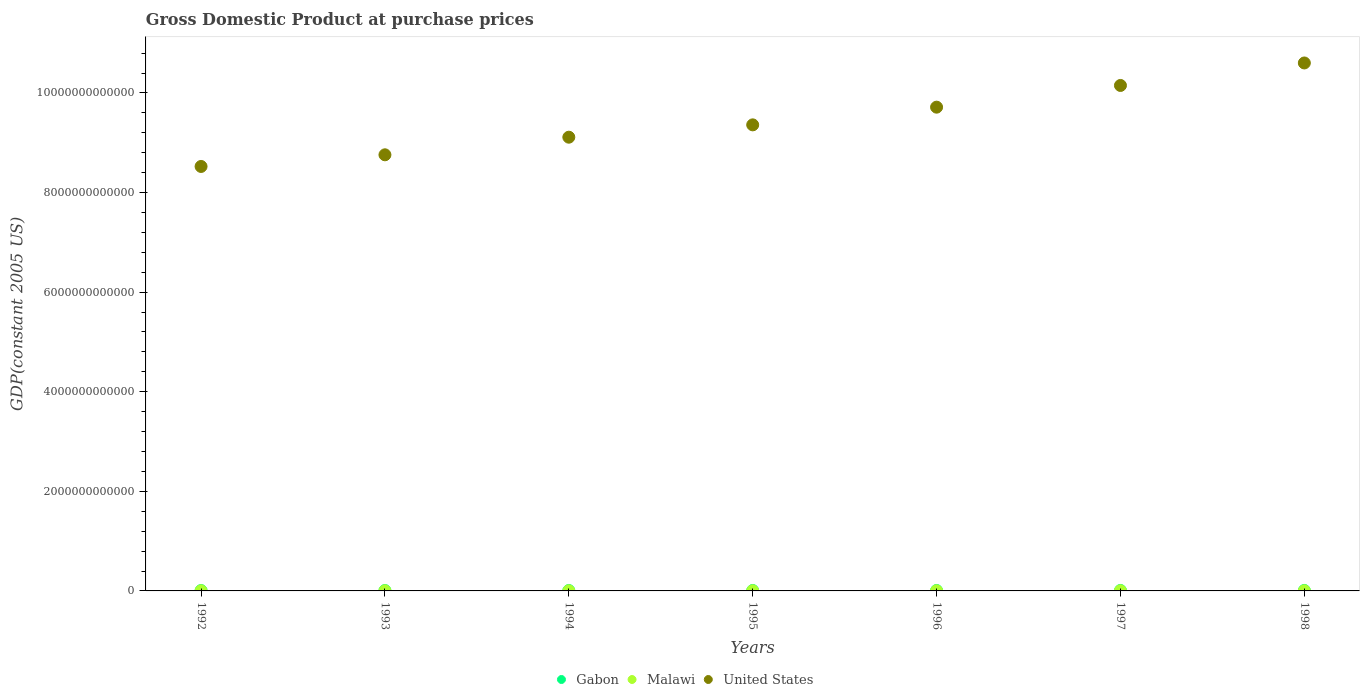Is the number of dotlines equal to the number of legend labels?
Your answer should be compact. Yes. What is the GDP at purchase prices in United States in 1994?
Offer a terse response. 9.11e+12. Across all years, what is the maximum GDP at purchase prices in Gabon?
Your response must be concise. 9.71e+09. Across all years, what is the minimum GDP at purchase prices in United States?
Keep it short and to the point. 8.52e+12. What is the total GDP at purchase prices in Gabon in the graph?
Make the answer very short. 6.01e+1. What is the difference between the GDP at purchase prices in Malawi in 1993 and that in 1994?
Provide a short and direct response. 2.02e+08. What is the difference between the GDP at purchase prices in Malawi in 1992 and the GDP at purchase prices in United States in 1997?
Provide a short and direct response. -1.01e+13. What is the average GDP at purchase prices in Gabon per year?
Provide a succinct answer. 8.59e+09. In the year 1996, what is the difference between the GDP at purchase prices in Malawi and GDP at purchase prices in Gabon?
Ensure brevity in your answer.  -6.66e+09. In how many years, is the GDP at purchase prices in United States greater than 2000000000000 US$?
Your answer should be very brief. 7. What is the ratio of the GDP at purchase prices in United States in 1994 to that in 1996?
Your answer should be compact. 0.94. Is the GDP at purchase prices in Gabon in 1993 less than that in 1998?
Ensure brevity in your answer.  Yes. Is the difference between the GDP at purchase prices in Malawi in 1995 and 1998 greater than the difference between the GDP at purchase prices in Gabon in 1995 and 1998?
Make the answer very short. Yes. What is the difference between the highest and the second highest GDP at purchase prices in Gabon?
Offer a very short reply. 3.26e+08. What is the difference between the highest and the lowest GDP at purchase prices in Malawi?
Ensure brevity in your answer.  6.22e+08. Is it the case that in every year, the sum of the GDP at purchase prices in Malawi and GDP at purchase prices in United States  is greater than the GDP at purchase prices in Gabon?
Make the answer very short. Yes. Is the GDP at purchase prices in United States strictly greater than the GDP at purchase prices in Gabon over the years?
Offer a terse response. Yes. What is the difference between two consecutive major ticks on the Y-axis?
Your answer should be very brief. 2.00e+12. Are the values on the major ticks of Y-axis written in scientific E-notation?
Your answer should be very brief. No. Does the graph contain grids?
Your answer should be very brief. No. What is the title of the graph?
Provide a succinct answer. Gross Domestic Product at purchase prices. Does "Pacific island small states" appear as one of the legend labels in the graph?
Give a very brief answer. No. What is the label or title of the Y-axis?
Provide a short and direct response. GDP(constant 2005 US). What is the GDP(constant 2005 US) of Gabon in 1992?
Offer a very short reply. 7.57e+09. What is the GDP(constant 2005 US) in Malawi in 1992?
Ensure brevity in your answer.  1.80e+09. What is the GDP(constant 2005 US) of United States in 1992?
Provide a succinct answer. 8.52e+12. What is the GDP(constant 2005 US) in Gabon in 1993?
Keep it short and to the point. 7.87e+09. What is the GDP(constant 2005 US) in Malawi in 1993?
Make the answer very short. 1.97e+09. What is the GDP(constant 2005 US) in United States in 1993?
Keep it short and to the point. 8.76e+12. What is the GDP(constant 2005 US) in Gabon in 1994?
Offer a very short reply. 8.16e+09. What is the GDP(constant 2005 US) of Malawi in 1994?
Provide a succinct answer. 1.77e+09. What is the GDP(constant 2005 US) in United States in 1994?
Give a very brief answer. 9.11e+12. What is the GDP(constant 2005 US) in Gabon in 1995?
Provide a succinct answer. 8.57e+09. What is the GDP(constant 2005 US) in Malawi in 1995?
Keep it short and to the point. 2.07e+09. What is the GDP(constant 2005 US) in United States in 1995?
Give a very brief answer. 9.36e+12. What is the GDP(constant 2005 US) in Gabon in 1996?
Your response must be concise. 8.88e+09. What is the GDP(constant 2005 US) in Malawi in 1996?
Ensure brevity in your answer.  2.22e+09. What is the GDP(constant 2005 US) in United States in 1996?
Make the answer very short. 9.71e+12. What is the GDP(constant 2005 US) in Gabon in 1997?
Provide a succinct answer. 9.39e+09. What is the GDP(constant 2005 US) in Malawi in 1997?
Offer a terse response. 2.30e+09. What is the GDP(constant 2005 US) in United States in 1997?
Provide a short and direct response. 1.02e+13. What is the GDP(constant 2005 US) of Gabon in 1998?
Your answer should be compact. 9.71e+09. What is the GDP(constant 2005 US) in Malawi in 1998?
Offer a terse response. 2.39e+09. What is the GDP(constant 2005 US) in United States in 1998?
Provide a succinct answer. 1.06e+13. Across all years, what is the maximum GDP(constant 2005 US) of Gabon?
Your response must be concise. 9.71e+09. Across all years, what is the maximum GDP(constant 2005 US) of Malawi?
Ensure brevity in your answer.  2.39e+09. Across all years, what is the maximum GDP(constant 2005 US) in United States?
Provide a short and direct response. 1.06e+13. Across all years, what is the minimum GDP(constant 2005 US) of Gabon?
Give a very brief answer. 7.57e+09. Across all years, what is the minimum GDP(constant 2005 US) of Malawi?
Provide a succinct answer. 1.77e+09. Across all years, what is the minimum GDP(constant 2005 US) in United States?
Make the answer very short. 8.52e+12. What is the total GDP(constant 2005 US) of Gabon in the graph?
Keep it short and to the point. 6.01e+1. What is the total GDP(constant 2005 US) of Malawi in the graph?
Keep it short and to the point. 1.45e+1. What is the total GDP(constant 2005 US) in United States in the graph?
Provide a short and direct response. 6.62e+13. What is the difference between the GDP(constant 2005 US) in Gabon in 1992 and that in 1993?
Offer a very short reply. -2.99e+08. What is the difference between the GDP(constant 2005 US) of Malawi in 1992 and that in 1993?
Your response must be concise. -1.74e+08. What is the difference between the GDP(constant 2005 US) of United States in 1992 and that in 1993?
Offer a very short reply. -2.34e+11. What is the difference between the GDP(constant 2005 US) of Gabon in 1992 and that in 1994?
Your answer should be compact. -5.91e+08. What is the difference between the GDP(constant 2005 US) of Malawi in 1992 and that in 1994?
Ensure brevity in your answer.  2.77e+07. What is the difference between the GDP(constant 2005 US) in United States in 1992 and that in 1994?
Make the answer very short. -5.88e+11. What is the difference between the GDP(constant 2005 US) of Gabon in 1992 and that in 1995?
Offer a very short reply. -9.97e+08. What is the difference between the GDP(constant 2005 US) of Malawi in 1992 and that in 1995?
Your answer should be very brief. -2.69e+08. What is the difference between the GDP(constant 2005 US) of United States in 1992 and that in 1995?
Offer a very short reply. -8.35e+11. What is the difference between the GDP(constant 2005 US) of Gabon in 1992 and that in 1996?
Provide a succinct answer. -1.31e+09. What is the difference between the GDP(constant 2005 US) in Malawi in 1992 and that in 1996?
Offer a terse response. -4.20e+08. What is the difference between the GDP(constant 2005 US) in United States in 1992 and that in 1996?
Ensure brevity in your answer.  -1.19e+12. What is the difference between the GDP(constant 2005 US) in Gabon in 1992 and that in 1997?
Your answer should be compact. -1.82e+09. What is the difference between the GDP(constant 2005 US) of Malawi in 1992 and that in 1997?
Provide a short and direct response. -5.04e+08. What is the difference between the GDP(constant 2005 US) of United States in 1992 and that in 1997?
Provide a short and direct response. -1.63e+12. What is the difference between the GDP(constant 2005 US) in Gabon in 1992 and that in 1998?
Your answer should be very brief. -2.14e+09. What is the difference between the GDP(constant 2005 US) of Malawi in 1992 and that in 1998?
Provide a succinct answer. -5.94e+08. What is the difference between the GDP(constant 2005 US) in United States in 1992 and that in 1998?
Ensure brevity in your answer.  -2.08e+12. What is the difference between the GDP(constant 2005 US) in Gabon in 1993 and that in 1994?
Offer a terse response. -2.92e+08. What is the difference between the GDP(constant 2005 US) of Malawi in 1993 and that in 1994?
Give a very brief answer. 2.02e+08. What is the difference between the GDP(constant 2005 US) of United States in 1993 and that in 1994?
Ensure brevity in your answer.  -3.54e+11. What is the difference between the GDP(constant 2005 US) of Gabon in 1993 and that in 1995?
Offer a very short reply. -6.98e+08. What is the difference between the GDP(constant 2005 US) in Malawi in 1993 and that in 1995?
Your answer should be compact. -9.43e+07. What is the difference between the GDP(constant 2005 US) of United States in 1993 and that in 1995?
Offer a very short reply. -6.01e+11. What is the difference between the GDP(constant 2005 US) of Gabon in 1993 and that in 1996?
Provide a succinct answer. -1.01e+09. What is the difference between the GDP(constant 2005 US) of Malawi in 1993 and that in 1996?
Provide a succinct answer. -2.46e+08. What is the difference between the GDP(constant 2005 US) in United States in 1993 and that in 1996?
Offer a terse response. -9.57e+11. What is the difference between the GDP(constant 2005 US) of Gabon in 1993 and that in 1997?
Offer a very short reply. -1.52e+09. What is the difference between the GDP(constant 2005 US) in Malawi in 1993 and that in 1997?
Provide a short and direct response. -3.30e+08. What is the difference between the GDP(constant 2005 US) of United States in 1993 and that in 1997?
Offer a terse response. -1.39e+12. What is the difference between the GDP(constant 2005 US) in Gabon in 1993 and that in 1998?
Provide a succinct answer. -1.84e+09. What is the difference between the GDP(constant 2005 US) of Malawi in 1993 and that in 1998?
Provide a succinct answer. -4.20e+08. What is the difference between the GDP(constant 2005 US) of United States in 1993 and that in 1998?
Offer a terse response. -1.84e+12. What is the difference between the GDP(constant 2005 US) in Gabon in 1994 and that in 1995?
Your response must be concise. -4.06e+08. What is the difference between the GDP(constant 2005 US) in Malawi in 1994 and that in 1995?
Your answer should be compact. -2.97e+08. What is the difference between the GDP(constant 2005 US) of United States in 1994 and that in 1995?
Keep it short and to the point. -2.48e+11. What is the difference between the GDP(constant 2005 US) of Gabon in 1994 and that in 1996?
Offer a terse response. -7.16e+08. What is the difference between the GDP(constant 2005 US) in Malawi in 1994 and that in 1996?
Provide a short and direct response. -4.48e+08. What is the difference between the GDP(constant 2005 US) of United States in 1994 and that in 1996?
Offer a very short reply. -6.03e+11. What is the difference between the GDP(constant 2005 US) of Gabon in 1994 and that in 1997?
Keep it short and to the point. -1.23e+09. What is the difference between the GDP(constant 2005 US) of Malawi in 1994 and that in 1997?
Provide a short and direct response. -5.32e+08. What is the difference between the GDP(constant 2005 US) in United States in 1994 and that in 1997?
Your answer should be very brief. -1.04e+12. What is the difference between the GDP(constant 2005 US) in Gabon in 1994 and that in 1998?
Provide a short and direct response. -1.55e+09. What is the difference between the GDP(constant 2005 US) of Malawi in 1994 and that in 1998?
Offer a terse response. -6.22e+08. What is the difference between the GDP(constant 2005 US) of United States in 1994 and that in 1998?
Make the answer very short. -1.49e+12. What is the difference between the GDP(constant 2005 US) of Gabon in 1995 and that in 1996?
Keep it short and to the point. -3.11e+08. What is the difference between the GDP(constant 2005 US) in Malawi in 1995 and that in 1996?
Make the answer very short. -1.51e+08. What is the difference between the GDP(constant 2005 US) in United States in 1995 and that in 1996?
Keep it short and to the point. -3.55e+11. What is the difference between the GDP(constant 2005 US) of Gabon in 1995 and that in 1997?
Provide a succinct answer. -8.20e+08. What is the difference between the GDP(constant 2005 US) in Malawi in 1995 and that in 1997?
Your answer should be very brief. -2.36e+08. What is the difference between the GDP(constant 2005 US) of United States in 1995 and that in 1997?
Keep it short and to the point. -7.91e+11. What is the difference between the GDP(constant 2005 US) of Gabon in 1995 and that in 1998?
Your answer should be compact. -1.15e+09. What is the difference between the GDP(constant 2005 US) of Malawi in 1995 and that in 1998?
Give a very brief answer. -3.25e+08. What is the difference between the GDP(constant 2005 US) in United States in 1995 and that in 1998?
Provide a short and direct response. -1.24e+12. What is the difference between the GDP(constant 2005 US) of Gabon in 1996 and that in 1997?
Your answer should be very brief. -5.09e+08. What is the difference between the GDP(constant 2005 US) in Malawi in 1996 and that in 1997?
Keep it short and to the point. -8.42e+07. What is the difference between the GDP(constant 2005 US) of United States in 1996 and that in 1997?
Your answer should be compact. -4.36e+11. What is the difference between the GDP(constant 2005 US) of Gabon in 1996 and that in 1998?
Offer a terse response. -8.36e+08. What is the difference between the GDP(constant 2005 US) in Malawi in 1996 and that in 1998?
Your response must be concise. -1.74e+08. What is the difference between the GDP(constant 2005 US) in United States in 1996 and that in 1998?
Ensure brevity in your answer.  -8.88e+11. What is the difference between the GDP(constant 2005 US) of Gabon in 1997 and that in 1998?
Provide a succinct answer. -3.26e+08. What is the difference between the GDP(constant 2005 US) in Malawi in 1997 and that in 1998?
Your answer should be very brief. -8.98e+07. What is the difference between the GDP(constant 2005 US) in United States in 1997 and that in 1998?
Provide a succinct answer. -4.52e+11. What is the difference between the GDP(constant 2005 US) of Gabon in 1992 and the GDP(constant 2005 US) of Malawi in 1993?
Provide a short and direct response. 5.60e+09. What is the difference between the GDP(constant 2005 US) in Gabon in 1992 and the GDP(constant 2005 US) in United States in 1993?
Offer a terse response. -8.75e+12. What is the difference between the GDP(constant 2005 US) in Malawi in 1992 and the GDP(constant 2005 US) in United States in 1993?
Offer a terse response. -8.76e+12. What is the difference between the GDP(constant 2005 US) of Gabon in 1992 and the GDP(constant 2005 US) of Malawi in 1994?
Provide a succinct answer. 5.80e+09. What is the difference between the GDP(constant 2005 US) in Gabon in 1992 and the GDP(constant 2005 US) in United States in 1994?
Your response must be concise. -9.10e+12. What is the difference between the GDP(constant 2005 US) in Malawi in 1992 and the GDP(constant 2005 US) in United States in 1994?
Provide a short and direct response. -9.11e+12. What is the difference between the GDP(constant 2005 US) in Gabon in 1992 and the GDP(constant 2005 US) in Malawi in 1995?
Your response must be concise. 5.50e+09. What is the difference between the GDP(constant 2005 US) of Gabon in 1992 and the GDP(constant 2005 US) of United States in 1995?
Your response must be concise. -9.35e+12. What is the difference between the GDP(constant 2005 US) of Malawi in 1992 and the GDP(constant 2005 US) of United States in 1995?
Provide a short and direct response. -9.36e+12. What is the difference between the GDP(constant 2005 US) of Gabon in 1992 and the GDP(constant 2005 US) of Malawi in 1996?
Your answer should be compact. 5.35e+09. What is the difference between the GDP(constant 2005 US) in Gabon in 1992 and the GDP(constant 2005 US) in United States in 1996?
Provide a short and direct response. -9.71e+12. What is the difference between the GDP(constant 2005 US) of Malawi in 1992 and the GDP(constant 2005 US) of United States in 1996?
Make the answer very short. -9.71e+12. What is the difference between the GDP(constant 2005 US) of Gabon in 1992 and the GDP(constant 2005 US) of Malawi in 1997?
Give a very brief answer. 5.27e+09. What is the difference between the GDP(constant 2005 US) of Gabon in 1992 and the GDP(constant 2005 US) of United States in 1997?
Ensure brevity in your answer.  -1.01e+13. What is the difference between the GDP(constant 2005 US) in Malawi in 1992 and the GDP(constant 2005 US) in United States in 1997?
Give a very brief answer. -1.01e+13. What is the difference between the GDP(constant 2005 US) of Gabon in 1992 and the GDP(constant 2005 US) of Malawi in 1998?
Your response must be concise. 5.18e+09. What is the difference between the GDP(constant 2005 US) in Gabon in 1992 and the GDP(constant 2005 US) in United States in 1998?
Ensure brevity in your answer.  -1.06e+13. What is the difference between the GDP(constant 2005 US) in Malawi in 1992 and the GDP(constant 2005 US) in United States in 1998?
Provide a succinct answer. -1.06e+13. What is the difference between the GDP(constant 2005 US) of Gabon in 1993 and the GDP(constant 2005 US) of Malawi in 1994?
Ensure brevity in your answer.  6.10e+09. What is the difference between the GDP(constant 2005 US) in Gabon in 1993 and the GDP(constant 2005 US) in United States in 1994?
Offer a very short reply. -9.10e+12. What is the difference between the GDP(constant 2005 US) in Malawi in 1993 and the GDP(constant 2005 US) in United States in 1994?
Provide a succinct answer. -9.11e+12. What is the difference between the GDP(constant 2005 US) of Gabon in 1993 and the GDP(constant 2005 US) of Malawi in 1995?
Your answer should be very brief. 5.80e+09. What is the difference between the GDP(constant 2005 US) in Gabon in 1993 and the GDP(constant 2005 US) in United States in 1995?
Give a very brief answer. -9.35e+12. What is the difference between the GDP(constant 2005 US) in Malawi in 1993 and the GDP(constant 2005 US) in United States in 1995?
Your answer should be very brief. -9.36e+12. What is the difference between the GDP(constant 2005 US) in Gabon in 1993 and the GDP(constant 2005 US) in Malawi in 1996?
Provide a short and direct response. 5.65e+09. What is the difference between the GDP(constant 2005 US) in Gabon in 1993 and the GDP(constant 2005 US) in United States in 1996?
Your answer should be compact. -9.71e+12. What is the difference between the GDP(constant 2005 US) of Malawi in 1993 and the GDP(constant 2005 US) of United States in 1996?
Ensure brevity in your answer.  -9.71e+12. What is the difference between the GDP(constant 2005 US) in Gabon in 1993 and the GDP(constant 2005 US) in Malawi in 1997?
Your response must be concise. 5.56e+09. What is the difference between the GDP(constant 2005 US) of Gabon in 1993 and the GDP(constant 2005 US) of United States in 1997?
Make the answer very short. -1.01e+13. What is the difference between the GDP(constant 2005 US) of Malawi in 1993 and the GDP(constant 2005 US) of United States in 1997?
Offer a terse response. -1.01e+13. What is the difference between the GDP(constant 2005 US) of Gabon in 1993 and the GDP(constant 2005 US) of Malawi in 1998?
Ensure brevity in your answer.  5.47e+09. What is the difference between the GDP(constant 2005 US) in Gabon in 1993 and the GDP(constant 2005 US) in United States in 1998?
Provide a short and direct response. -1.06e+13. What is the difference between the GDP(constant 2005 US) in Malawi in 1993 and the GDP(constant 2005 US) in United States in 1998?
Ensure brevity in your answer.  -1.06e+13. What is the difference between the GDP(constant 2005 US) of Gabon in 1994 and the GDP(constant 2005 US) of Malawi in 1995?
Your answer should be very brief. 6.09e+09. What is the difference between the GDP(constant 2005 US) of Gabon in 1994 and the GDP(constant 2005 US) of United States in 1995?
Give a very brief answer. -9.35e+12. What is the difference between the GDP(constant 2005 US) in Malawi in 1994 and the GDP(constant 2005 US) in United States in 1995?
Keep it short and to the point. -9.36e+12. What is the difference between the GDP(constant 2005 US) in Gabon in 1994 and the GDP(constant 2005 US) in Malawi in 1996?
Your response must be concise. 5.94e+09. What is the difference between the GDP(constant 2005 US) of Gabon in 1994 and the GDP(constant 2005 US) of United States in 1996?
Keep it short and to the point. -9.71e+12. What is the difference between the GDP(constant 2005 US) of Malawi in 1994 and the GDP(constant 2005 US) of United States in 1996?
Give a very brief answer. -9.71e+12. What is the difference between the GDP(constant 2005 US) of Gabon in 1994 and the GDP(constant 2005 US) of Malawi in 1997?
Offer a terse response. 5.86e+09. What is the difference between the GDP(constant 2005 US) of Gabon in 1994 and the GDP(constant 2005 US) of United States in 1997?
Offer a very short reply. -1.01e+13. What is the difference between the GDP(constant 2005 US) of Malawi in 1994 and the GDP(constant 2005 US) of United States in 1997?
Ensure brevity in your answer.  -1.01e+13. What is the difference between the GDP(constant 2005 US) in Gabon in 1994 and the GDP(constant 2005 US) in Malawi in 1998?
Give a very brief answer. 5.77e+09. What is the difference between the GDP(constant 2005 US) in Gabon in 1994 and the GDP(constant 2005 US) in United States in 1998?
Your answer should be very brief. -1.06e+13. What is the difference between the GDP(constant 2005 US) in Malawi in 1994 and the GDP(constant 2005 US) in United States in 1998?
Your response must be concise. -1.06e+13. What is the difference between the GDP(constant 2005 US) in Gabon in 1995 and the GDP(constant 2005 US) in Malawi in 1996?
Ensure brevity in your answer.  6.35e+09. What is the difference between the GDP(constant 2005 US) of Gabon in 1995 and the GDP(constant 2005 US) of United States in 1996?
Your response must be concise. -9.71e+12. What is the difference between the GDP(constant 2005 US) of Malawi in 1995 and the GDP(constant 2005 US) of United States in 1996?
Keep it short and to the point. -9.71e+12. What is the difference between the GDP(constant 2005 US) in Gabon in 1995 and the GDP(constant 2005 US) in Malawi in 1997?
Keep it short and to the point. 6.26e+09. What is the difference between the GDP(constant 2005 US) in Gabon in 1995 and the GDP(constant 2005 US) in United States in 1997?
Provide a succinct answer. -1.01e+13. What is the difference between the GDP(constant 2005 US) of Malawi in 1995 and the GDP(constant 2005 US) of United States in 1997?
Give a very brief answer. -1.01e+13. What is the difference between the GDP(constant 2005 US) of Gabon in 1995 and the GDP(constant 2005 US) of Malawi in 1998?
Offer a very short reply. 6.17e+09. What is the difference between the GDP(constant 2005 US) of Gabon in 1995 and the GDP(constant 2005 US) of United States in 1998?
Provide a short and direct response. -1.06e+13. What is the difference between the GDP(constant 2005 US) in Malawi in 1995 and the GDP(constant 2005 US) in United States in 1998?
Keep it short and to the point. -1.06e+13. What is the difference between the GDP(constant 2005 US) in Gabon in 1996 and the GDP(constant 2005 US) in Malawi in 1997?
Offer a terse response. 6.57e+09. What is the difference between the GDP(constant 2005 US) in Gabon in 1996 and the GDP(constant 2005 US) in United States in 1997?
Your response must be concise. -1.01e+13. What is the difference between the GDP(constant 2005 US) of Malawi in 1996 and the GDP(constant 2005 US) of United States in 1997?
Ensure brevity in your answer.  -1.01e+13. What is the difference between the GDP(constant 2005 US) of Gabon in 1996 and the GDP(constant 2005 US) of Malawi in 1998?
Offer a very short reply. 6.48e+09. What is the difference between the GDP(constant 2005 US) of Gabon in 1996 and the GDP(constant 2005 US) of United States in 1998?
Offer a very short reply. -1.06e+13. What is the difference between the GDP(constant 2005 US) of Malawi in 1996 and the GDP(constant 2005 US) of United States in 1998?
Provide a succinct answer. -1.06e+13. What is the difference between the GDP(constant 2005 US) in Gabon in 1997 and the GDP(constant 2005 US) in Malawi in 1998?
Make the answer very short. 6.99e+09. What is the difference between the GDP(constant 2005 US) in Gabon in 1997 and the GDP(constant 2005 US) in United States in 1998?
Provide a succinct answer. -1.06e+13. What is the difference between the GDP(constant 2005 US) in Malawi in 1997 and the GDP(constant 2005 US) in United States in 1998?
Offer a terse response. -1.06e+13. What is the average GDP(constant 2005 US) of Gabon per year?
Provide a short and direct response. 8.59e+09. What is the average GDP(constant 2005 US) in Malawi per year?
Your response must be concise. 2.08e+09. What is the average GDP(constant 2005 US) of United States per year?
Offer a terse response. 9.46e+12. In the year 1992, what is the difference between the GDP(constant 2005 US) in Gabon and GDP(constant 2005 US) in Malawi?
Provide a succinct answer. 5.77e+09. In the year 1992, what is the difference between the GDP(constant 2005 US) in Gabon and GDP(constant 2005 US) in United States?
Provide a succinct answer. -8.52e+12. In the year 1992, what is the difference between the GDP(constant 2005 US) in Malawi and GDP(constant 2005 US) in United States?
Your response must be concise. -8.52e+12. In the year 1993, what is the difference between the GDP(constant 2005 US) of Gabon and GDP(constant 2005 US) of Malawi?
Offer a terse response. 5.89e+09. In the year 1993, what is the difference between the GDP(constant 2005 US) in Gabon and GDP(constant 2005 US) in United States?
Ensure brevity in your answer.  -8.75e+12. In the year 1993, what is the difference between the GDP(constant 2005 US) in Malawi and GDP(constant 2005 US) in United States?
Your answer should be compact. -8.76e+12. In the year 1994, what is the difference between the GDP(constant 2005 US) in Gabon and GDP(constant 2005 US) in Malawi?
Provide a succinct answer. 6.39e+09. In the year 1994, what is the difference between the GDP(constant 2005 US) in Gabon and GDP(constant 2005 US) in United States?
Offer a very short reply. -9.10e+12. In the year 1994, what is the difference between the GDP(constant 2005 US) of Malawi and GDP(constant 2005 US) of United States?
Your response must be concise. -9.11e+12. In the year 1995, what is the difference between the GDP(constant 2005 US) in Gabon and GDP(constant 2005 US) in Malawi?
Offer a terse response. 6.50e+09. In the year 1995, what is the difference between the GDP(constant 2005 US) in Gabon and GDP(constant 2005 US) in United States?
Your answer should be compact. -9.35e+12. In the year 1995, what is the difference between the GDP(constant 2005 US) in Malawi and GDP(constant 2005 US) in United States?
Offer a very short reply. -9.36e+12. In the year 1996, what is the difference between the GDP(constant 2005 US) in Gabon and GDP(constant 2005 US) in Malawi?
Keep it short and to the point. 6.66e+09. In the year 1996, what is the difference between the GDP(constant 2005 US) in Gabon and GDP(constant 2005 US) in United States?
Make the answer very short. -9.71e+12. In the year 1996, what is the difference between the GDP(constant 2005 US) in Malawi and GDP(constant 2005 US) in United States?
Your answer should be compact. -9.71e+12. In the year 1997, what is the difference between the GDP(constant 2005 US) in Gabon and GDP(constant 2005 US) in Malawi?
Your answer should be very brief. 7.08e+09. In the year 1997, what is the difference between the GDP(constant 2005 US) of Gabon and GDP(constant 2005 US) of United States?
Your answer should be compact. -1.01e+13. In the year 1997, what is the difference between the GDP(constant 2005 US) in Malawi and GDP(constant 2005 US) in United States?
Your response must be concise. -1.01e+13. In the year 1998, what is the difference between the GDP(constant 2005 US) in Gabon and GDP(constant 2005 US) in Malawi?
Make the answer very short. 7.32e+09. In the year 1998, what is the difference between the GDP(constant 2005 US) of Gabon and GDP(constant 2005 US) of United States?
Make the answer very short. -1.06e+13. In the year 1998, what is the difference between the GDP(constant 2005 US) of Malawi and GDP(constant 2005 US) of United States?
Your answer should be compact. -1.06e+13. What is the ratio of the GDP(constant 2005 US) in Malawi in 1992 to that in 1993?
Ensure brevity in your answer.  0.91. What is the ratio of the GDP(constant 2005 US) of United States in 1992 to that in 1993?
Your answer should be compact. 0.97. What is the ratio of the GDP(constant 2005 US) in Gabon in 1992 to that in 1994?
Keep it short and to the point. 0.93. What is the ratio of the GDP(constant 2005 US) of Malawi in 1992 to that in 1994?
Provide a succinct answer. 1.02. What is the ratio of the GDP(constant 2005 US) in United States in 1992 to that in 1994?
Give a very brief answer. 0.94. What is the ratio of the GDP(constant 2005 US) of Gabon in 1992 to that in 1995?
Offer a very short reply. 0.88. What is the ratio of the GDP(constant 2005 US) in Malawi in 1992 to that in 1995?
Provide a short and direct response. 0.87. What is the ratio of the GDP(constant 2005 US) in United States in 1992 to that in 1995?
Offer a terse response. 0.91. What is the ratio of the GDP(constant 2005 US) in Gabon in 1992 to that in 1996?
Provide a short and direct response. 0.85. What is the ratio of the GDP(constant 2005 US) of Malawi in 1992 to that in 1996?
Give a very brief answer. 0.81. What is the ratio of the GDP(constant 2005 US) of United States in 1992 to that in 1996?
Keep it short and to the point. 0.88. What is the ratio of the GDP(constant 2005 US) of Gabon in 1992 to that in 1997?
Give a very brief answer. 0.81. What is the ratio of the GDP(constant 2005 US) in Malawi in 1992 to that in 1997?
Keep it short and to the point. 0.78. What is the ratio of the GDP(constant 2005 US) in United States in 1992 to that in 1997?
Ensure brevity in your answer.  0.84. What is the ratio of the GDP(constant 2005 US) of Gabon in 1992 to that in 1998?
Offer a terse response. 0.78. What is the ratio of the GDP(constant 2005 US) of Malawi in 1992 to that in 1998?
Make the answer very short. 0.75. What is the ratio of the GDP(constant 2005 US) in United States in 1992 to that in 1998?
Your answer should be very brief. 0.8. What is the ratio of the GDP(constant 2005 US) in Gabon in 1993 to that in 1994?
Ensure brevity in your answer.  0.96. What is the ratio of the GDP(constant 2005 US) of Malawi in 1993 to that in 1994?
Your answer should be very brief. 1.11. What is the ratio of the GDP(constant 2005 US) of United States in 1993 to that in 1994?
Offer a very short reply. 0.96. What is the ratio of the GDP(constant 2005 US) of Gabon in 1993 to that in 1995?
Offer a terse response. 0.92. What is the ratio of the GDP(constant 2005 US) in Malawi in 1993 to that in 1995?
Provide a succinct answer. 0.95. What is the ratio of the GDP(constant 2005 US) in United States in 1993 to that in 1995?
Your response must be concise. 0.94. What is the ratio of the GDP(constant 2005 US) of Gabon in 1993 to that in 1996?
Ensure brevity in your answer.  0.89. What is the ratio of the GDP(constant 2005 US) of Malawi in 1993 to that in 1996?
Keep it short and to the point. 0.89. What is the ratio of the GDP(constant 2005 US) of United States in 1993 to that in 1996?
Make the answer very short. 0.9. What is the ratio of the GDP(constant 2005 US) in Gabon in 1993 to that in 1997?
Offer a very short reply. 0.84. What is the ratio of the GDP(constant 2005 US) of Malawi in 1993 to that in 1997?
Offer a very short reply. 0.86. What is the ratio of the GDP(constant 2005 US) of United States in 1993 to that in 1997?
Offer a very short reply. 0.86. What is the ratio of the GDP(constant 2005 US) in Gabon in 1993 to that in 1998?
Keep it short and to the point. 0.81. What is the ratio of the GDP(constant 2005 US) in Malawi in 1993 to that in 1998?
Provide a succinct answer. 0.82. What is the ratio of the GDP(constant 2005 US) of United States in 1993 to that in 1998?
Offer a terse response. 0.83. What is the ratio of the GDP(constant 2005 US) in Gabon in 1994 to that in 1995?
Give a very brief answer. 0.95. What is the ratio of the GDP(constant 2005 US) of Malawi in 1994 to that in 1995?
Keep it short and to the point. 0.86. What is the ratio of the GDP(constant 2005 US) of United States in 1994 to that in 1995?
Make the answer very short. 0.97. What is the ratio of the GDP(constant 2005 US) in Gabon in 1994 to that in 1996?
Provide a succinct answer. 0.92. What is the ratio of the GDP(constant 2005 US) in Malawi in 1994 to that in 1996?
Offer a terse response. 0.8. What is the ratio of the GDP(constant 2005 US) of United States in 1994 to that in 1996?
Give a very brief answer. 0.94. What is the ratio of the GDP(constant 2005 US) of Gabon in 1994 to that in 1997?
Provide a succinct answer. 0.87. What is the ratio of the GDP(constant 2005 US) of Malawi in 1994 to that in 1997?
Provide a succinct answer. 0.77. What is the ratio of the GDP(constant 2005 US) of United States in 1994 to that in 1997?
Provide a succinct answer. 0.9. What is the ratio of the GDP(constant 2005 US) of Gabon in 1994 to that in 1998?
Offer a very short reply. 0.84. What is the ratio of the GDP(constant 2005 US) in Malawi in 1994 to that in 1998?
Your answer should be compact. 0.74. What is the ratio of the GDP(constant 2005 US) in United States in 1994 to that in 1998?
Provide a succinct answer. 0.86. What is the ratio of the GDP(constant 2005 US) in Gabon in 1995 to that in 1996?
Offer a very short reply. 0.96. What is the ratio of the GDP(constant 2005 US) of Malawi in 1995 to that in 1996?
Offer a very short reply. 0.93. What is the ratio of the GDP(constant 2005 US) of United States in 1995 to that in 1996?
Provide a short and direct response. 0.96. What is the ratio of the GDP(constant 2005 US) in Gabon in 1995 to that in 1997?
Keep it short and to the point. 0.91. What is the ratio of the GDP(constant 2005 US) in Malawi in 1995 to that in 1997?
Your answer should be very brief. 0.9. What is the ratio of the GDP(constant 2005 US) in United States in 1995 to that in 1997?
Ensure brevity in your answer.  0.92. What is the ratio of the GDP(constant 2005 US) in Gabon in 1995 to that in 1998?
Provide a succinct answer. 0.88. What is the ratio of the GDP(constant 2005 US) of Malawi in 1995 to that in 1998?
Offer a terse response. 0.86. What is the ratio of the GDP(constant 2005 US) in United States in 1995 to that in 1998?
Your answer should be compact. 0.88. What is the ratio of the GDP(constant 2005 US) of Gabon in 1996 to that in 1997?
Your answer should be very brief. 0.95. What is the ratio of the GDP(constant 2005 US) in Malawi in 1996 to that in 1997?
Your answer should be very brief. 0.96. What is the ratio of the GDP(constant 2005 US) of United States in 1996 to that in 1997?
Make the answer very short. 0.96. What is the ratio of the GDP(constant 2005 US) of Gabon in 1996 to that in 1998?
Provide a succinct answer. 0.91. What is the ratio of the GDP(constant 2005 US) in Malawi in 1996 to that in 1998?
Your answer should be compact. 0.93. What is the ratio of the GDP(constant 2005 US) in United States in 1996 to that in 1998?
Offer a terse response. 0.92. What is the ratio of the GDP(constant 2005 US) of Gabon in 1997 to that in 1998?
Make the answer very short. 0.97. What is the ratio of the GDP(constant 2005 US) of Malawi in 1997 to that in 1998?
Your answer should be compact. 0.96. What is the ratio of the GDP(constant 2005 US) of United States in 1997 to that in 1998?
Provide a succinct answer. 0.96. What is the difference between the highest and the second highest GDP(constant 2005 US) in Gabon?
Provide a succinct answer. 3.26e+08. What is the difference between the highest and the second highest GDP(constant 2005 US) in Malawi?
Give a very brief answer. 8.98e+07. What is the difference between the highest and the second highest GDP(constant 2005 US) in United States?
Offer a terse response. 4.52e+11. What is the difference between the highest and the lowest GDP(constant 2005 US) of Gabon?
Provide a short and direct response. 2.14e+09. What is the difference between the highest and the lowest GDP(constant 2005 US) of Malawi?
Offer a very short reply. 6.22e+08. What is the difference between the highest and the lowest GDP(constant 2005 US) in United States?
Keep it short and to the point. 2.08e+12. 